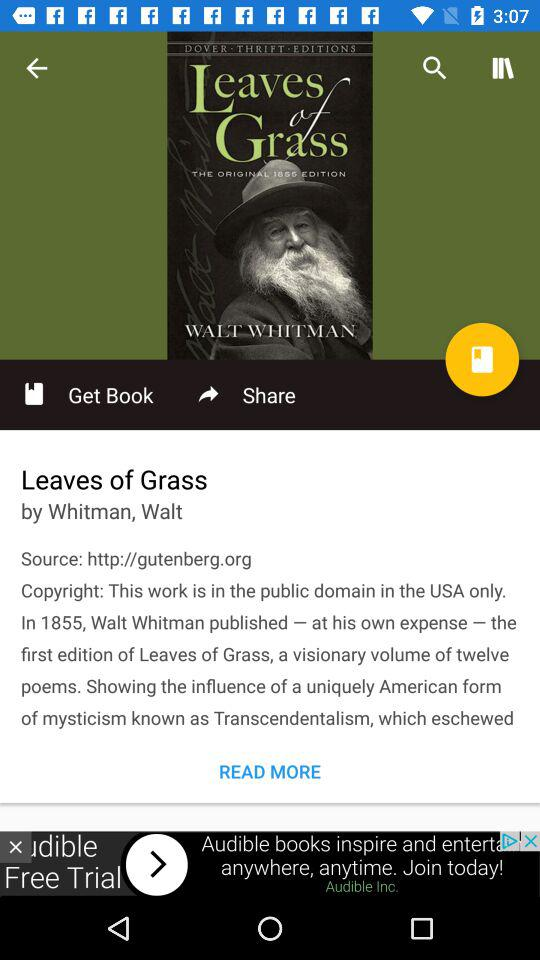Who is the author of "Leaves of Grass"? The author of "Leaves of Grass" is Walt Whitman. 